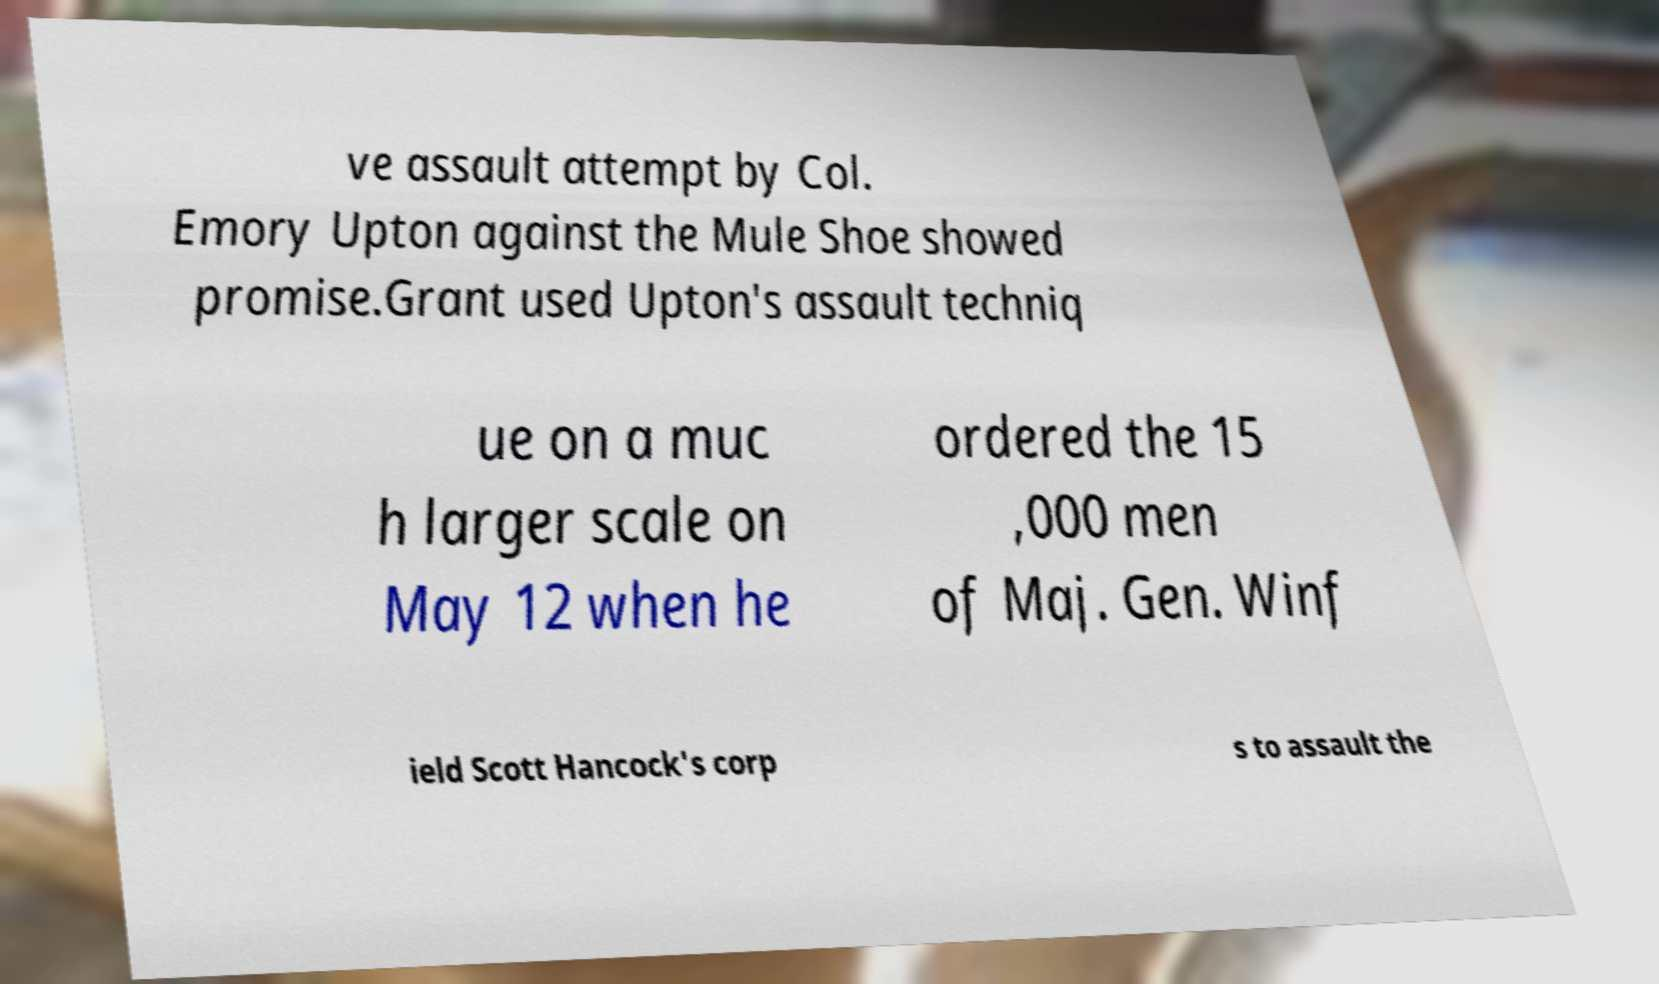What messages or text are displayed in this image? I need them in a readable, typed format. ve assault attempt by Col. Emory Upton against the Mule Shoe showed promise.Grant used Upton's assault techniq ue on a muc h larger scale on May 12 when he ordered the 15 ,000 men of Maj. Gen. Winf ield Scott Hancock's corp s to assault the 